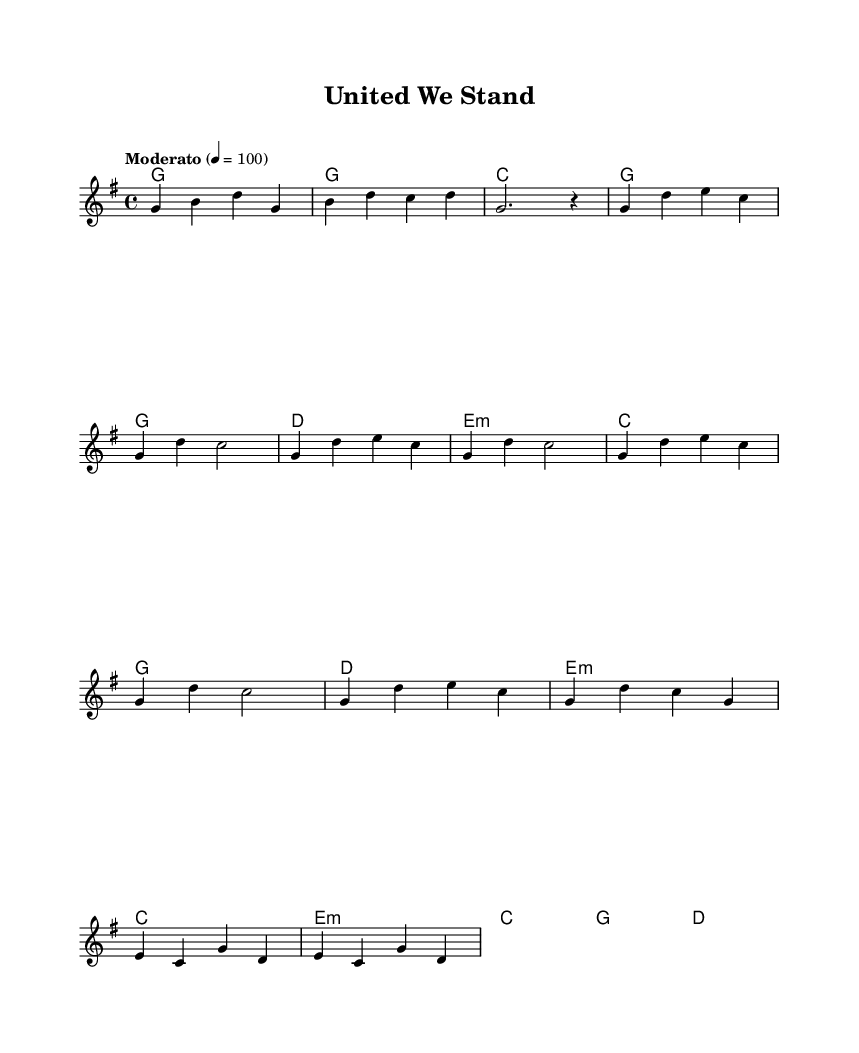What is the key signature of this music? The key signature indicated in the sheet music is G major, which has one sharp (F#). This can be identified in the global section of the code where it states "\key g \major".
Answer: G major What is the time signature of this music? The time signature is 4/4, which is mentioned in the global section of the code with "\time 4/4". In a 4/4 time signature, there are four beats in each measure, and the quarter note gets the beat.
Answer: 4/4 What is the tempo marking for this piece? The tempo is indicated as "Moderato" with a metronome marking of 100 beats per minute. This is specified in the global section where it states "\tempo 'Moderato' 4 = 100".
Answer: Moderato How many measures are in the chorus? The chorus section consists of four measures, identified by the lines under the "Chorus" in the code. Each measure contains a musical phrase, and counting them gives a total of four.
Answer: 4 What is the main theme of the lyrics in the verse? The lyrics of the verse convey unity and perseverance, discussing themes of togetherness and ongoing effort. This can be inferred from the words in the lyricmode sections labeled "verseOne", which expresses the idea of standing together as one.
Answer: Unity What are the three colors mentioned in the bridge? The colors mentioned in the bridge are red, white, and blue, which are symbolic of the American flag. This can be found in the "bridge" section of the lyrics where it specifically states "Red, white, and blue".
Answer: Red, white, and blue What is the harmonic structure used in the chorus? The harmonic structure in the chorus primarily uses the chords G, D, E minor, and C. This can be observed in the chordmode section corresponding to the chorus, where these chords are repeated throughout the measures.
Answer: G, D, E minor, C 